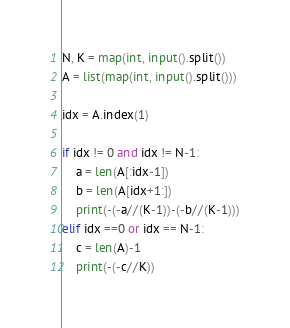Convert code to text. <code><loc_0><loc_0><loc_500><loc_500><_Python_>N, K = map(int, input().split())
A = list(map(int, input().split()))

idx = A.index(1)

if idx != 0 and idx != N-1:
    a = len(A[:idx-1])
    b = len(A[idx+1:])
    print(-(-a//(K-1))-(-b//(K-1)))
elif idx ==0 or idx == N-1:
    c = len(A)-1
    print(-(-c//K))</code> 